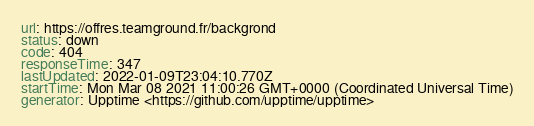Convert code to text. <code><loc_0><loc_0><loc_500><loc_500><_YAML_>url: https://offres.teamground.fr/backgrond
status: down
code: 404
responseTime: 347
lastUpdated: 2022-01-09T23:04:10.770Z
startTime: Mon Mar 08 2021 11:00:26 GMT+0000 (Coordinated Universal Time)
generator: Upptime <https://github.com/upptime/upptime>
</code> 